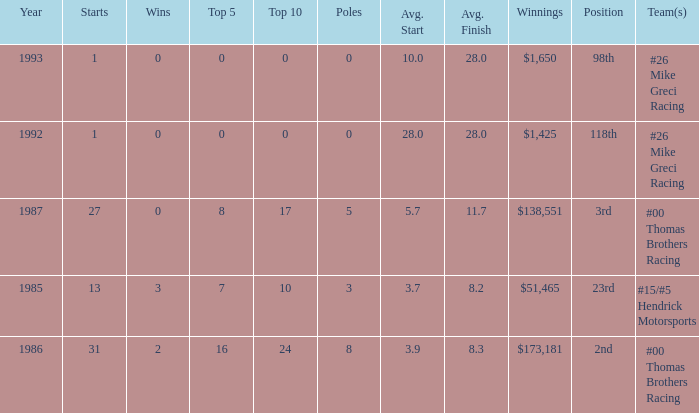How many years did he have an average finish of 11.7? 1.0. 